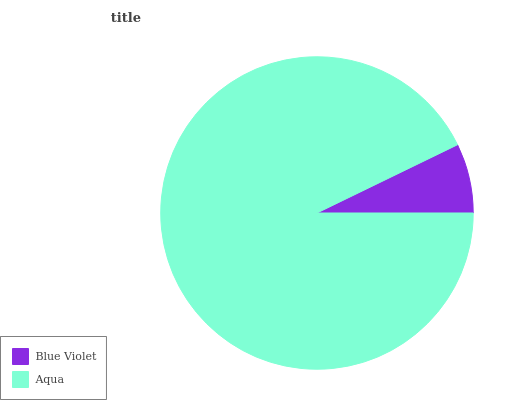Is Blue Violet the minimum?
Answer yes or no. Yes. Is Aqua the maximum?
Answer yes or no. Yes. Is Aqua the minimum?
Answer yes or no. No. Is Aqua greater than Blue Violet?
Answer yes or no. Yes. Is Blue Violet less than Aqua?
Answer yes or no. Yes. Is Blue Violet greater than Aqua?
Answer yes or no. No. Is Aqua less than Blue Violet?
Answer yes or no. No. Is Aqua the high median?
Answer yes or no. Yes. Is Blue Violet the low median?
Answer yes or no. Yes. Is Blue Violet the high median?
Answer yes or no. No. Is Aqua the low median?
Answer yes or no. No. 